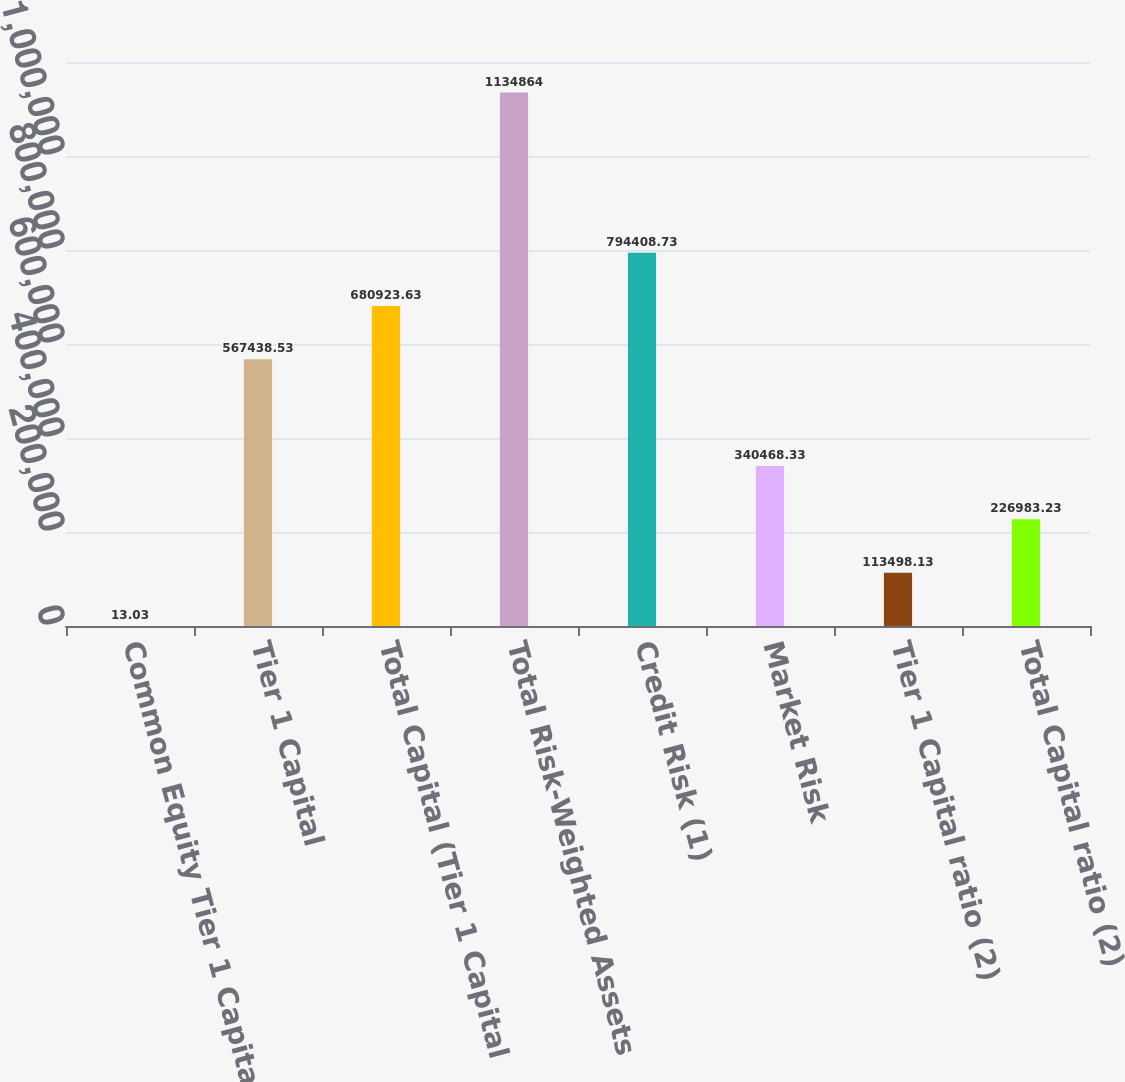Convert chart to OTSL. <chart><loc_0><loc_0><loc_500><loc_500><bar_chart><fcel>Common Equity Tier 1 Capital<fcel>Tier 1 Capital<fcel>Total Capital (Tier 1 Capital<fcel>Total Risk-Weighted Assets<fcel>Credit Risk (1)<fcel>Market Risk<fcel>Tier 1 Capital ratio (2)<fcel>Total Capital ratio (2)<nl><fcel>13.03<fcel>567439<fcel>680924<fcel>1.13486e+06<fcel>794409<fcel>340468<fcel>113498<fcel>226983<nl></chart> 